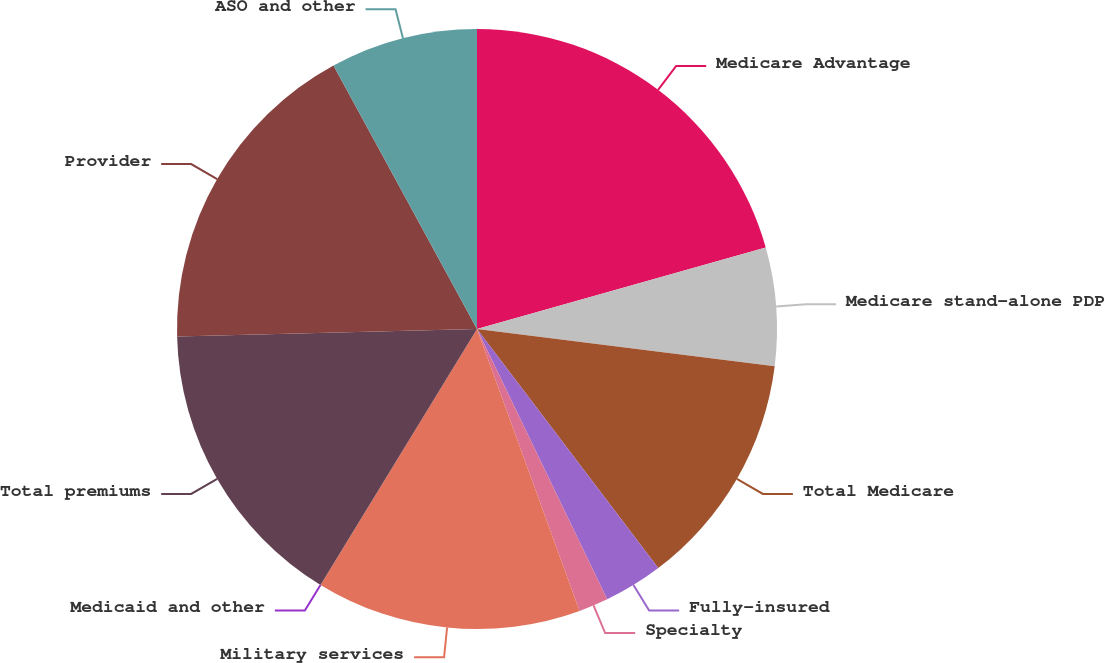Convert chart. <chart><loc_0><loc_0><loc_500><loc_500><pie_chart><fcel>Medicare Advantage<fcel>Medicare stand-alone PDP<fcel>Total Medicare<fcel>Fully-insured<fcel>Specialty<fcel>Military services<fcel>Medicaid and other<fcel>Total premiums<fcel>Provider<fcel>ASO and other<nl><fcel>20.63%<fcel>6.35%<fcel>12.7%<fcel>3.18%<fcel>1.59%<fcel>14.29%<fcel>0.0%<fcel>15.87%<fcel>17.46%<fcel>7.94%<nl></chart> 